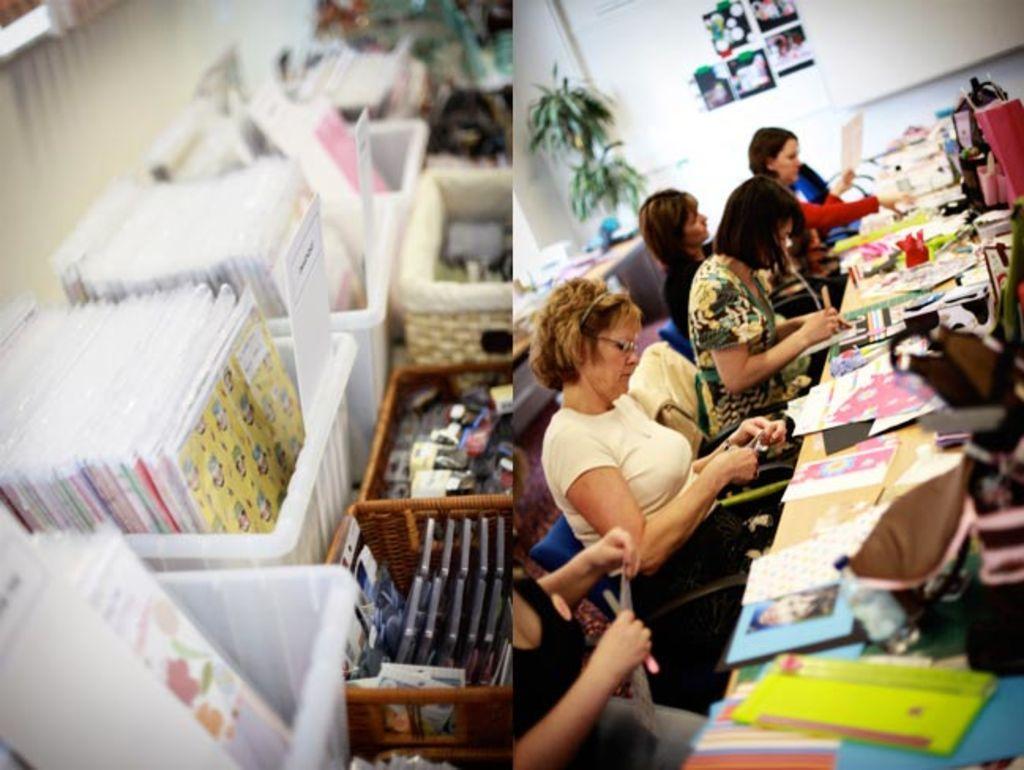In one or two sentences, can you explain what this image depicts? We can see two images. On the left side image we can see cards in the plastic boxes and other objects in the boxes on a platform and we can see the wall. On the right side image we can see few persons are sitting on the chairs at the table and on the table we can see cards, bags and objects and in the background we can see papers attached on the wall, plant and objects on a table. 